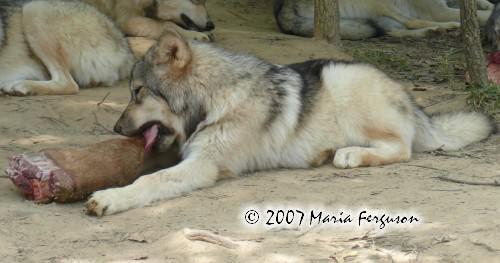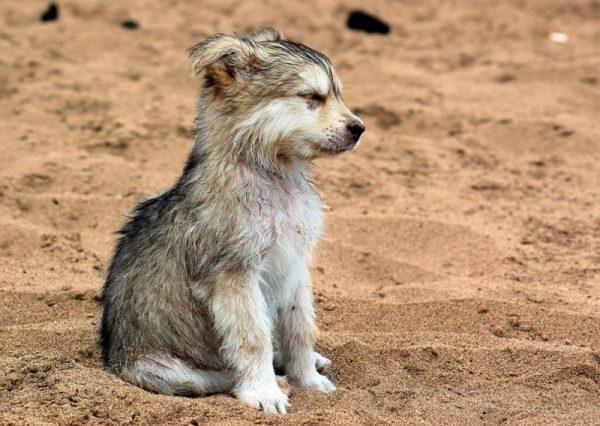The first image is the image on the left, the second image is the image on the right. Assess this claim about the two images: "There is a wolf in the water.". Correct or not? Answer yes or no. No. The first image is the image on the left, the second image is the image on the right. Assess this claim about the two images: "In the right image, one wolf has its open jaw around part of a wolf pup.". Correct or not? Answer yes or no. No. 